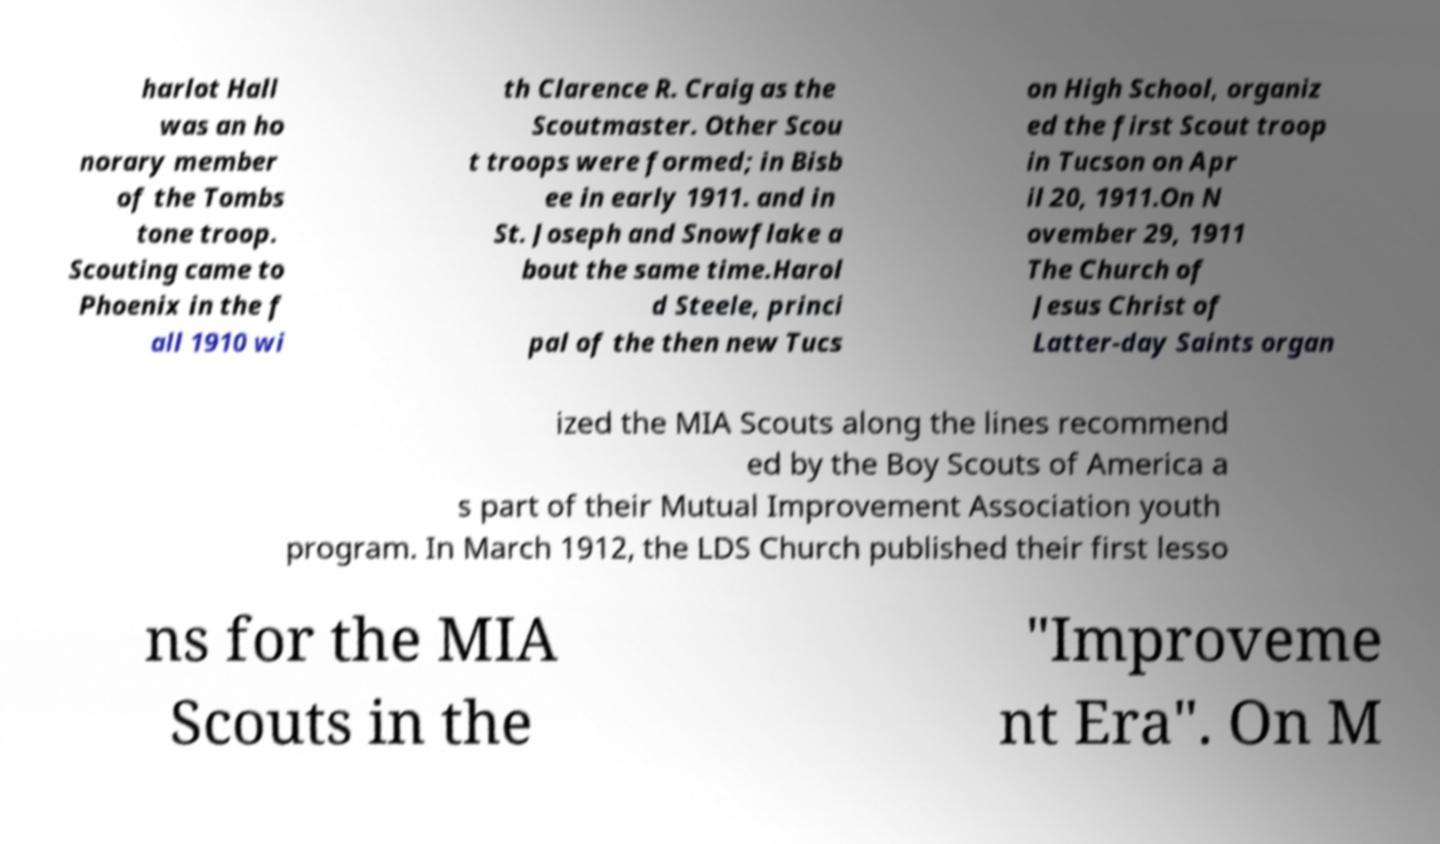Could you extract and type out the text from this image? harlot Hall was an ho norary member of the Tombs tone troop. Scouting came to Phoenix in the f all 1910 wi th Clarence R. Craig as the Scoutmaster. Other Scou t troops were formed; in Bisb ee in early 1911. and in St. Joseph and Snowflake a bout the same time.Harol d Steele, princi pal of the then new Tucs on High School, organiz ed the first Scout troop in Tucson on Apr il 20, 1911.On N ovember 29, 1911 The Church of Jesus Christ of Latter-day Saints organ ized the MIA Scouts along the lines recommend ed by the Boy Scouts of America a s part of their Mutual Improvement Association youth program. In March 1912, the LDS Church published their first lesso ns for the MIA Scouts in the "Improveme nt Era". On M 